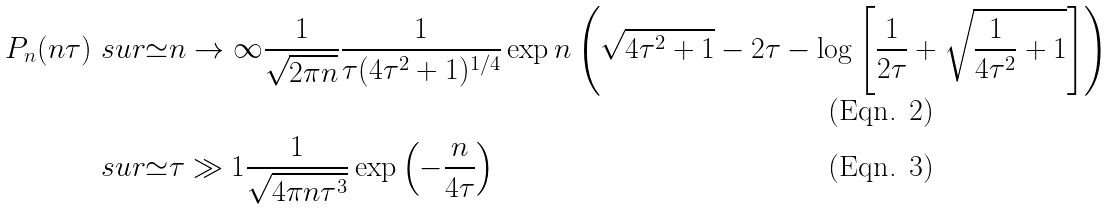Convert formula to latex. <formula><loc_0><loc_0><loc_500><loc_500>P _ { n } ( n \tau ) & \ s u r { \simeq } { n \rightarrow \infty } \frac { 1 } { \sqrt { 2 \pi n } } \frac { 1 } { \tau ( 4 \tau ^ { 2 } + 1 ) ^ { 1 / 4 } } \exp n \left ( \sqrt { 4 \tau ^ { 2 } + 1 } - 2 \tau - \log \left [ \frac { 1 } { 2 \tau } + \sqrt { \frac { 1 } { 4 \tau ^ { 2 } } + 1 } \right ] \right ) \\ & \ s u r { \simeq } { \tau \gg 1 } \frac { 1 } { \sqrt { 4 \pi n \tau ^ { 3 } } } \exp \left ( - \frac { n } { 4 \tau } \right )</formula> 